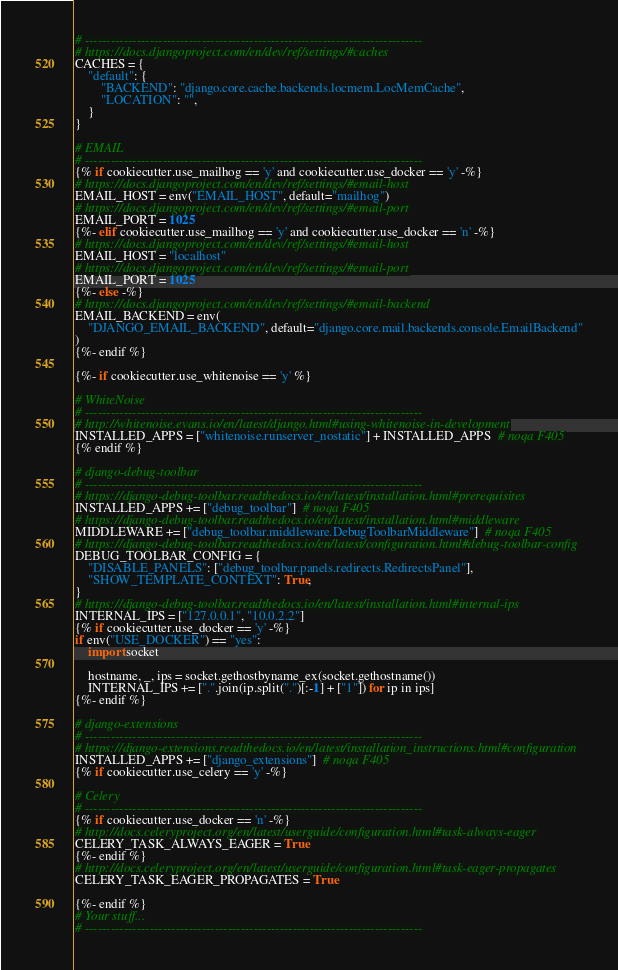Convert code to text. <code><loc_0><loc_0><loc_500><loc_500><_Python_># ------------------------------------------------------------------------------
# https://docs.djangoproject.com/en/dev/ref/settings/#caches
CACHES = {
    "default": {
        "BACKEND": "django.core.cache.backends.locmem.LocMemCache",
        "LOCATION": "",
    }
}

# EMAIL
# ------------------------------------------------------------------------------
{% if cookiecutter.use_mailhog == 'y' and cookiecutter.use_docker == 'y' -%}
# https://docs.djangoproject.com/en/dev/ref/settings/#email-host
EMAIL_HOST = env("EMAIL_HOST", default="mailhog")
# https://docs.djangoproject.com/en/dev/ref/settings/#email-port
EMAIL_PORT = 1025
{%- elif cookiecutter.use_mailhog == 'y' and cookiecutter.use_docker == 'n' -%}
# https://docs.djangoproject.com/en/dev/ref/settings/#email-host
EMAIL_HOST = "localhost"
# https://docs.djangoproject.com/en/dev/ref/settings/#email-port
EMAIL_PORT = 1025
{%- else -%}
# https://docs.djangoproject.com/en/dev/ref/settings/#email-backend
EMAIL_BACKEND = env(
    "DJANGO_EMAIL_BACKEND", default="django.core.mail.backends.console.EmailBackend"
)
{%- endif %}

{%- if cookiecutter.use_whitenoise == 'y' %}

# WhiteNoise
# ------------------------------------------------------------------------------
# http://whitenoise.evans.io/en/latest/django.html#using-whitenoise-in-development
INSTALLED_APPS = ["whitenoise.runserver_nostatic"] + INSTALLED_APPS  # noqa F405
{% endif %}

# django-debug-toolbar
# ------------------------------------------------------------------------------
# https://django-debug-toolbar.readthedocs.io/en/latest/installation.html#prerequisites
INSTALLED_APPS += ["debug_toolbar"]  # noqa F405
# https://django-debug-toolbar.readthedocs.io/en/latest/installation.html#middleware
MIDDLEWARE += ["debug_toolbar.middleware.DebugToolbarMiddleware"]  # noqa F405
# https://django-debug-toolbar.readthedocs.io/en/latest/configuration.html#debug-toolbar-config
DEBUG_TOOLBAR_CONFIG = {
    "DISABLE_PANELS": ["debug_toolbar.panels.redirects.RedirectsPanel"],
    "SHOW_TEMPLATE_CONTEXT": True,
}
# https://django-debug-toolbar.readthedocs.io/en/latest/installation.html#internal-ips
INTERNAL_IPS = ["127.0.0.1", "10.0.2.2"]
{% if cookiecutter.use_docker == 'y' -%}
if env("USE_DOCKER") == "yes":
    import socket

    hostname, _, ips = socket.gethostbyname_ex(socket.gethostname())
    INTERNAL_IPS += [".".join(ip.split(".")[:-1] + ["1"]) for ip in ips]
{%- endif %}

# django-extensions
# ------------------------------------------------------------------------------
# https://django-extensions.readthedocs.io/en/latest/installation_instructions.html#configuration
INSTALLED_APPS += ["django_extensions"]  # noqa F405
{% if cookiecutter.use_celery == 'y' -%}

# Celery
# ------------------------------------------------------------------------------
{% if cookiecutter.use_docker == 'n' -%}
# http://docs.celeryproject.org/en/latest/userguide/configuration.html#task-always-eager
CELERY_TASK_ALWAYS_EAGER = True
{%- endif %}
# http://docs.celeryproject.org/en/latest/userguide/configuration.html#task-eager-propagates
CELERY_TASK_EAGER_PROPAGATES = True

{%- endif %}
# Your stuff...
# ------------------------------------------------------------------------------
</code> 